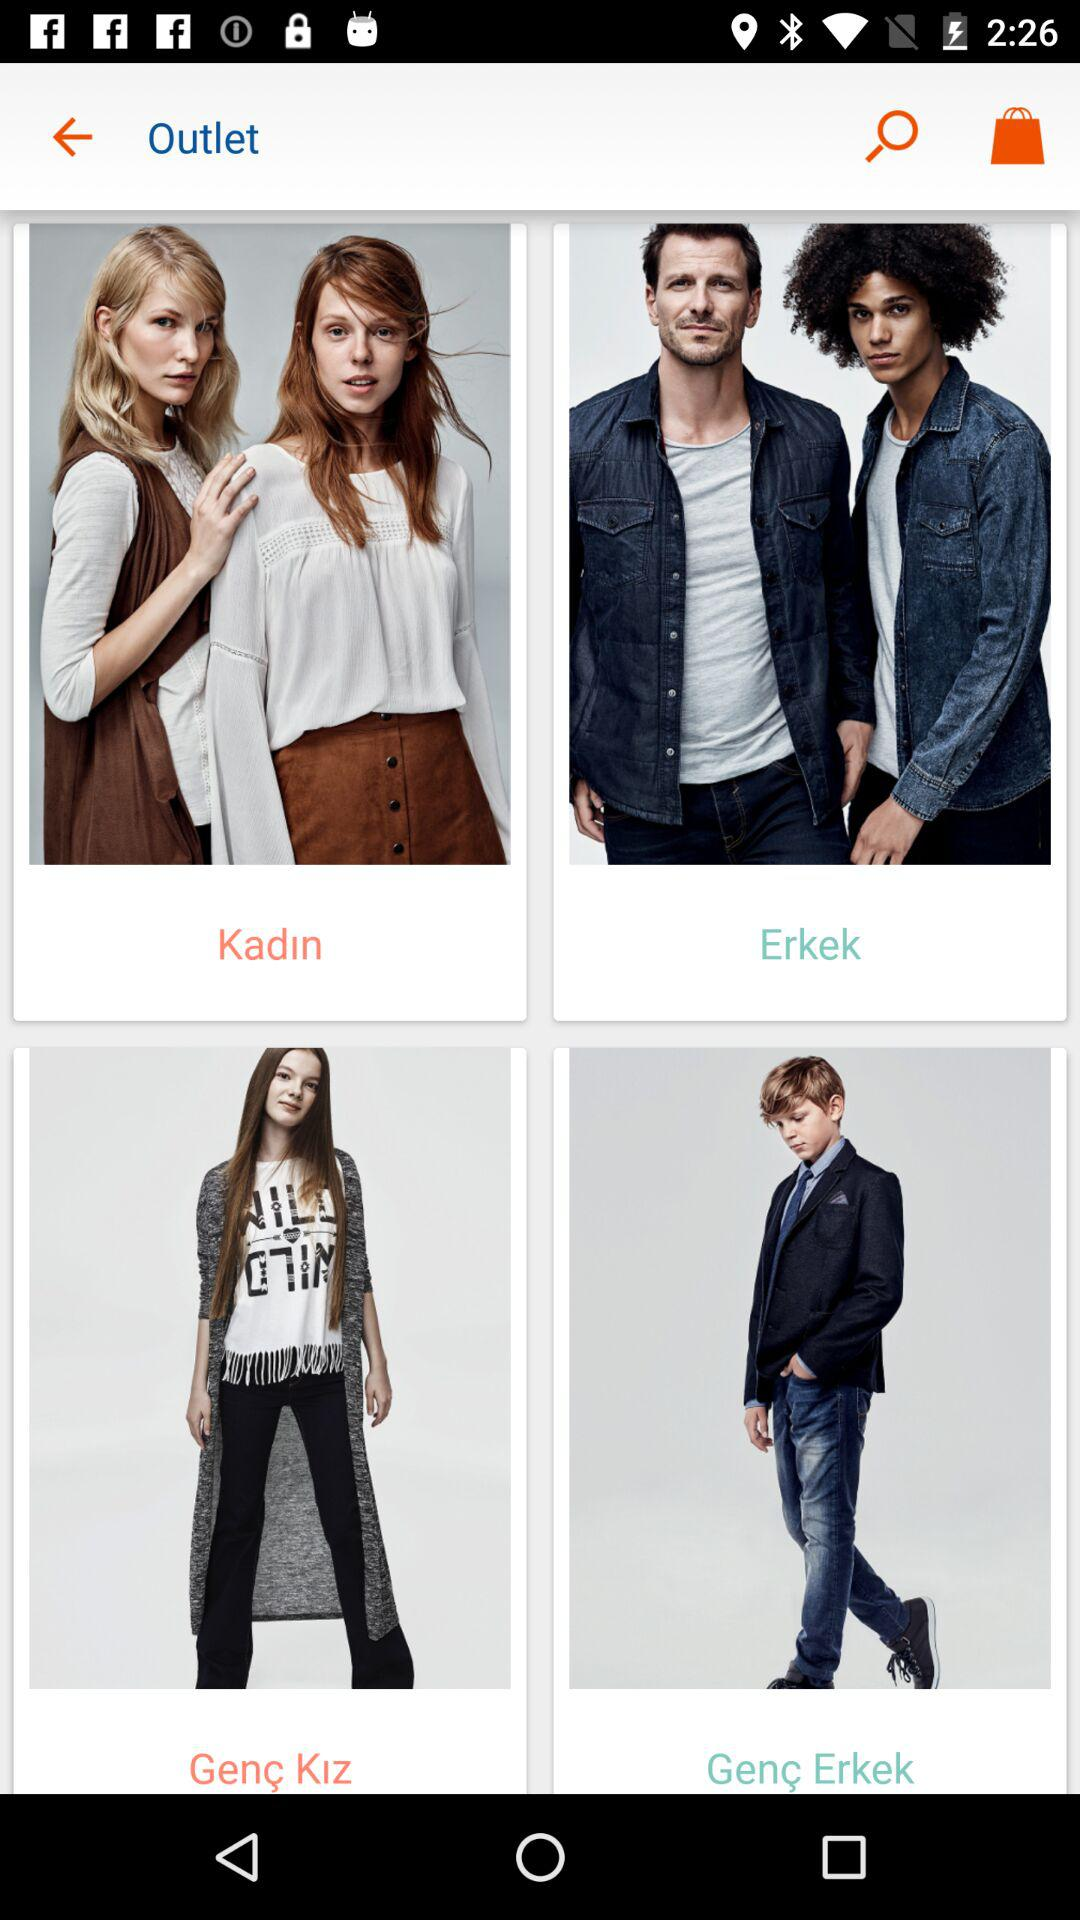How many items are there in total?
Answer the question using a single word or phrase. 4 